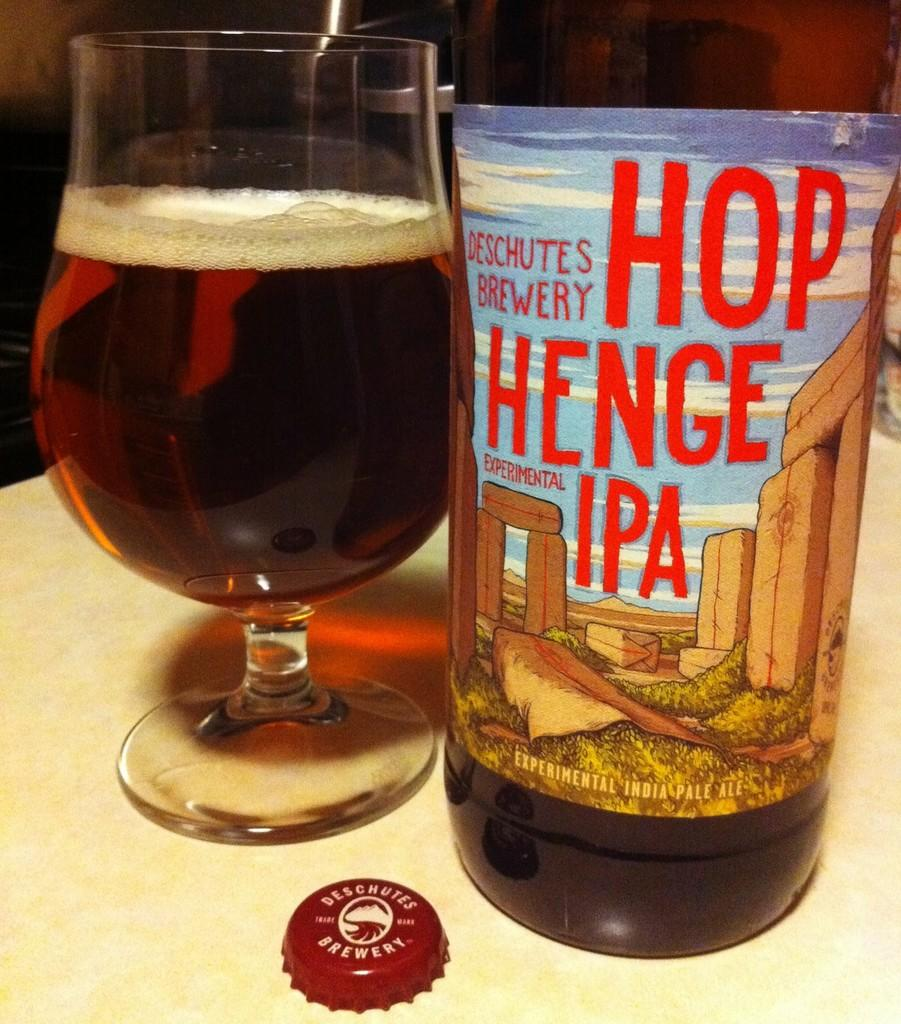What is present on the table in the image? There is a bottle and a wine glass with a drink in the image. What type of drink is in the wine glass? The provided facts do not specify the type of drink in the wine glass. Where are the bottle and the wine glass located? Both the bottle and the wine glass are on a table. What is the price of the pleasure experienced by the cloud in the image? There is no cloud present in the image, and the concept of a cloud experiencing pleasure is not applicable. 